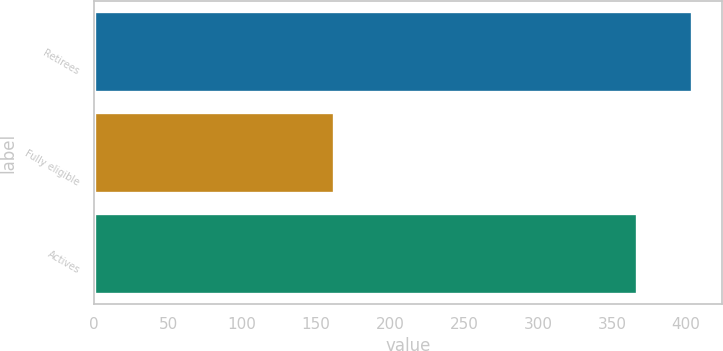Convert chart to OTSL. <chart><loc_0><loc_0><loc_500><loc_500><bar_chart><fcel>Retirees<fcel>Fully eligible<fcel>Actives<nl><fcel>404<fcel>162<fcel>367<nl></chart> 